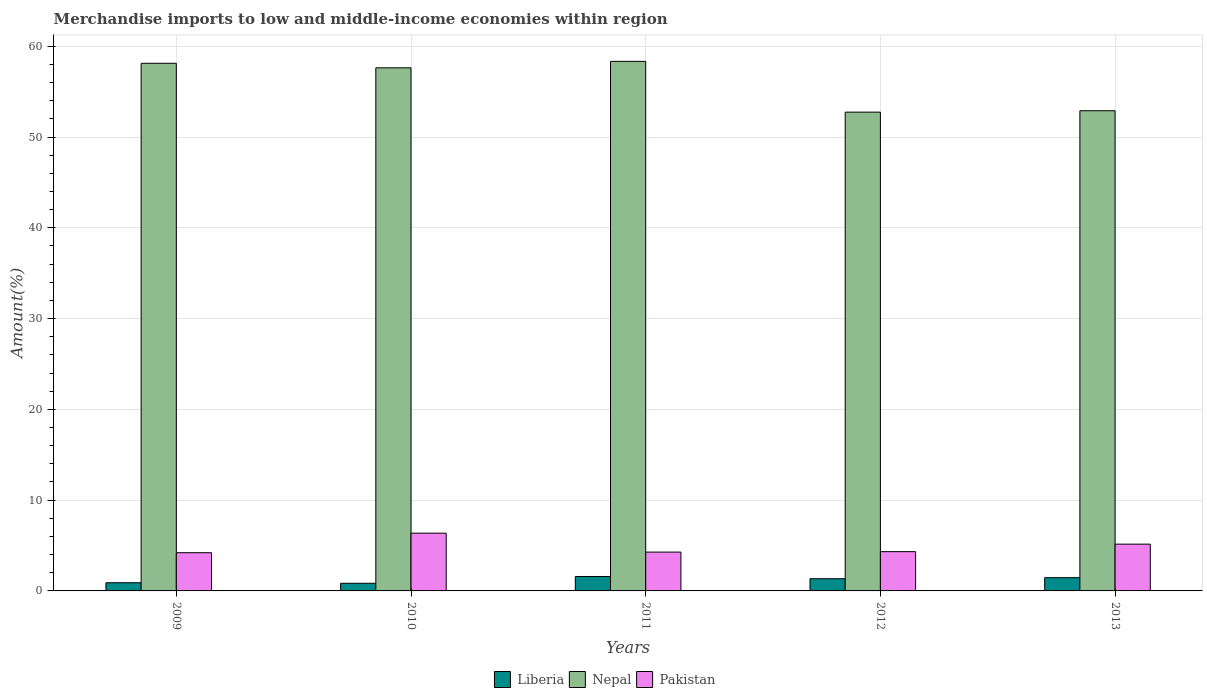How many groups of bars are there?
Offer a very short reply. 5. Are the number of bars per tick equal to the number of legend labels?
Ensure brevity in your answer.  Yes. How many bars are there on the 2nd tick from the right?
Offer a very short reply. 3. In how many cases, is the number of bars for a given year not equal to the number of legend labels?
Provide a short and direct response. 0. What is the percentage of amount earned from merchandise imports in Pakistan in 2010?
Provide a short and direct response. 6.36. Across all years, what is the maximum percentage of amount earned from merchandise imports in Nepal?
Give a very brief answer. 58.33. Across all years, what is the minimum percentage of amount earned from merchandise imports in Pakistan?
Provide a succinct answer. 4.21. In which year was the percentage of amount earned from merchandise imports in Liberia maximum?
Your answer should be compact. 2011. In which year was the percentage of amount earned from merchandise imports in Pakistan minimum?
Your answer should be very brief. 2009. What is the total percentage of amount earned from merchandise imports in Liberia in the graph?
Keep it short and to the point. 6.13. What is the difference between the percentage of amount earned from merchandise imports in Nepal in 2011 and that in 2013?
Your response must be concise. 5.44. What is the difference between the percentage of amount earned from merchandise imports in Pakistan in 2011 and the percentage of amount earned from merchandise imports in Liberia in 2009?
Offer a very short reply. 3.38. What is the average percentage of amount earned from merchandise imports in Liberia per year?
Ensure brevity in your answer.  1.23. In the year 2010, what is the difference between the percentage of amount earned from merchandise imports in Liberia and percentage of amount earned from merchandise imports in Nepal?
Your answer should be very brief. -56.78. In how many years, is the percentage of amount earned from merchandise imports in Pakistan greater than 36 %?
Give a very brief answer. 0. What is the ratio of the percentage of amount earned from merchandise imports in Nepal in 2009 to that in 2012?
Keep it short and to the point. 1.1. Is the percentage of amount earned from merchandise imports in Pakistan in 2010 less than that in 2012?
Offer a terse response. No. Is the difference between the percentage of amount earned from merchandise imports in Liberia in 2010 and 2012 greater than the difference between the percentage of amount earned from merchandise imports in Nepal in 2010 and 2012?
Provide a short and direct response. No. What is the difference between the highest and the second highest percentage of amount earned from merchandise imports in Nepal?
Give a very brief answer. 0.21. What is the difference between the highest and the lowest percentage of amount earned from merchandise imports in Liberia?
Make the answer very short. 0.75. Is the sum of the percentage of amount earned from merchandise imports in Nepal in 2009 and 2012 greater than the maximum percentage of amount earned from merchandise imports in Liberia across all years?
Give a very brief answer. Yes. What does the 2nd bar from the left in 2013 represents?
Keep it short and to the point. Nepal. What does the 3rd bar from the right in 2011 represents?
Provide a short and direct response. Liberia. How many bars are there?
Your answer should be compact. 15. What is the difference between two consecutive major ticks on the Y-axis?
Offer a very short reply. 10. Does the graph contain grids?
Provide a succinct answer. Yes. How many legend labels are there?
Provide a short and direct response. 3. How are the legend labels stacked?
Provide a short and direct response. Horizontal. What is the title of the graph?
Your answer should be very brief. Merchandise imports to low and middle-income economies within region. What is the label or title of the Y-axis?
Keep it short and to the point. Amount(%). What is the Amount(%) in Liberia in 2009?
Give a very brief answer. 0.9. What is the Amount(%) in Nepal in 2009?
Ensure brevity in your answer.  58.12. What is the Amount(%) of Pakistan in 2009?
Provide a succinct answer. 4.21. What is the Amount(%) in Liberia in 2010?
Provide a succinct answer. 0.84. What is the Amount(%) of Nepal in 2010?
Your answer should be compact. 57.62. What is the Amount(%) in Pakistan in 2010?
Provide a short and direct response. 6.36. What is the Amount(%) in Liberia in 2011?
Provide a short and direct response. 1.59. What is the Amount(%) of Nepal in 2011?
Make the answer very short. 58.33. What is the Amount(%) in Pakistan in 2011?
Your answer should be compact. 4.28. What is the Amount(%) of Liberia in 2012?
Provide a short and direct response. 1.34. What is the Amount(%) in Nepal in 2012?
Give a very brief answer. 52.74. What is the Amount(%) in Pakistan in 2012?
Give a very brief answer. 4.33. What is the Amount(%) in Liberia in 2013?
Provide a succinct answer. 1.46. What is the Amount(%) in Nepal in 2013?
Your response must be concise. 52.89. What is the Amount(%) in Pakistan in 2013?
Ensure brevity in your answer.  5.15. Across all years, what is the maximum Amount(%) of Liberia?
Offer a very short reply. 1.59. Across all years, what is the maximum Amount(%) in Nepal?
Make the answer very short. 58.33. Across all years, what is the maximum Amount(%) in Pakistan?
Your response must be concise. 6.36. Across all years, what is the minimum Amount(%) in Liberia?
Give a very brief answer. 0.84. Across all years, what is the minimum Amount(%) in Nepal?
Offer a terse response. 52.74. Across all years, what is the minimum Amount(%) of Pakistan?
Keep it short and to the point. 4.21. What is the total Amount(%) of Liberia in the graph?
Make the answer very short. 6.13. What is the total Amount(%) in Nepal in the graph?
Offer a very short reply. 279.71. What is the total Amount(%) in Pakistan in the graph?
Give a very brief answer. 24.33. What is the difference between the Amount(%) of Liberia in 2009 and that in 2010?
Provide a short and direct response. 0.06. What is the difference between the Amount(%) of Nepal in 2009 and that in 2010?
Your answer should be compact. 0.5. What is the difference between the Amount(%) of Pakistan in 2009 and that in 2010?
Provide a succinct answer. -2.15. What is the difference between the Amount(%) of Liberia in 2009 and that in 2011?
Your answer should be very brief. -0.69. What is the difference between the Amount(%) in Nepal in 2009 and that in 2011?
Ensure brevity in your answer.  -0.21. What is the difference between the Amount(%) of Pakistan in 2009 and that in 2011?
Your answer should be compact. -0.07. What is the difference between the Amount(%) of Liberia in 2009 and that in 2012?
Offer a terse response. -0.44. What is the difference between the Amount(%) in Nepal in 2009 and that in 2012?
Your answer should be very brief. 5.38. What is the difference between the Amount(%) in Pakistan in 2009 and that in 2012?
Keep it short and to the point. -0.12. What is the difference between the Amount(%) in Liberia in 2009 and that in 2013?
Your answer should be very brief. -0.56. What is the difference between the Amount(%) of Nepal in 2009 and that in 2013?
Your response must be concise. 5.23. What is the difference between the Amount(%) of Pakistan in 2009 and that in 2013?
Make the answer very short. -0.94. What is the difference between the Amount(%) in Liberia in 2010 and that in 2011?
Offer a very short reply. -0.75. What is the difference between the Amount(%) of Nepal in 2010 and that in 2011?
Provide a succinct answer. -0.71. What is the difference between the Amount(%) in Pakistan in 2010 and that in 2011?
Ensure brevity in your answer.  2.08. What is the difference between the Amount(%) in Liberia in 2010 and that in 2012?
Give a very brief answer. -0.5. What is the difference between the Amount(%) in Nepal in 2010 and that in 2012?
Give a very brief answer. 4.88. What is the difference between the Amount(%) in Pakistan in 2010 and that in 2012?
Your response must be concise. 2.04. What is the difference between the Amount(%) in Liberia in 2010 and that in 2013?
Offer a terse response. -0.62. What is the difference between the Amount(%) of Nepal in 2010 and that in 2013?
Offer a terse response. 4.73. What is the difference between the Amount(%) in Pakistan in 2010 and that in 2013?
Make the answer very short. 1.21. What is the difference between the Amount(%) of Liberia in 2011 and that in 2012?
Provide a short and direct response. 0.25. What is the difference between the Amount(%) of Nepal in 2011 and that in 2012?
Make the answer very short. 5.59. What is the difference between the Amount(%) of Pakistan in 2011 and that in 2012?
Offer a very short reply. -0.05. What is the difference between the Amount(%) in Liberia in 2011 and that in 2013?
Your answer should be very brief. 0.13. What is the difference between the Amount(%) in Nepal in 2011 and that in 2013?
Ensure brevity in your answer.  5.44. What is the difference between the Amount(%) of Pakistan in 2011 and that in 2013?
Offer a terse response. -0.87. What is the difference between the Amount(%) in Liberia in 2012 and that in 2013?
Your answer should be very brief. -0.12. What is the difference between the Amount(%) in Nepal in 2012 and that in 2013?
Your answer should be compact. -0.15. What is the difference between the Amount(%) in Pakistan in 2012 and that in 2013?
Offer a terse response. -0.83. What is the difference between the Amount(%) of Liberia in 2009 and the Amount(%) of Nepal in 2010?
Your answer should be very brief. -56.72. What is the difference between the Amount(%) of Liberia in 2009 and the Amount(%) of Pakistan in 2010?
Offer a very short reply. -5.46. What is the difference between the Amount(%) in Nepal in 2009 and the Amount(%) in Pakistan in 2010?
Offer a very short reply. 51.76. What is the difference between the Amount(%) in Liberia in 2009 and the Amount(%) in Nepal in 2011?
Your answer should be compact. -57.43. What is the difference between the Amount(%) in Liberia in 2009 and the Amount(%) in Pakistan in 2011?
Ensure brevity in your answer.  -3.38. What is the difference between the Amount(%) in Nepal in 2009 and the Amount(%) in Pakistan in 2011?
Your answer should be very brief. 53.84. What is the difference between the Amount(%) in Liberia in 2009 and the Amount(%) in Nepal in 2012?
Provide a short and direct response. -51.84. What is the difference between the Amount(%) in Liberia in 2009 and the Amount(%) in Pakistan in 2012?
Your answer should be compact. -3.42. What is the difference between the Amount(%) in Nepal in 2009 and the Amount(%) in Pakistan in 2012?
Ensure brevity in your answer.  53.8. What is the difference between the Amount(%) in Liberia in 2009 and the Amount(%) in Nepal in 2013?
Give a very brief answer. -51.99. What is the difference between the Amount(%) in Liberia in 2009 and the Amount(%) in Pakistan in 2013?
Provide a short and direct response. -4.25. What is the difference between the Amount(%) in Nepal in 2009 and the Amount(%) in Pakistan in 2013?
Your answer should be very brief. 52.97. What is the difference between the Amount(%) of Liberia in 2010 and the Amount(%) of Nepal in 2011?
Keep it short and to the point. -57.49. What is the difference between the Amount(%) of Liberia in 2010 and the Amount(%) of Pakistan in 2011?
Keep it short and to the point. -3.43. What is the difference between the Amount(%) in Nepal in 2010 and the Amount(%) in Pakistan in 2011?
Give a very brief answer. 53.34. What is the difference between the Amount(%) of Liberia in 2010 and the Amount(%) of Nepal in 2012?
Your answer should be very brief. -51.9. What is the difference between the Amount(%) in Liberia in 2010 and the Amount(%) in Pakistan in 2012?
Provide a short and direct response. -3.48. What is the difference between the Amount(%) in Nepal in 2010 and the Amount(%) in Pakistan in 2012?
Give a very brief answer. 53.3. What is the difference between the Amount(%) in Liberia in 2010 and the Amount(%) in Nepal in 2013?
Your answer should be compact. -52.05. What is the difference between the Amount(%) of Liberia in 2010 and the Amount(%) of Pakistan in 2013?
Give a very brief answer. -4.31. What is the difference between the Amount(%) of Nepal in 2010 and the Amount(%) of Pakistan in 2013?
Your response must be concise. 52.47. What is the difference between the Amount(%) of Liberia in 2011 and the Amount(%) of Nepal in 2012?
Make the answer very short. -51.15. What is the difference between the Amount(%) in Liberia in 2011 and the Amount(%) in Pakistan in 2012?
Give a very brief answer. -2.74. What is the difference between the Amount(%) in Nepal in 2011 and the Amount(%) in Pakistan in 2012?
Provide a short and direct response. 54.01. What is the difference between the Amount(%) of Liberia in 2011 and the Amount(%) of Nepal in 2013?
Offer a very short reply. -51.3. What is the difference between the Amount(%) of Liberia in 2011 and the Amount(%) of Pakistan in 2013?
Offer a very short reply. -3.56. What is the difference between the Amount(%) in Nepal in 2011 and the Amount(%) in Pakistan in 2013?
Make the answer very short. 53.18. What is the difference between the Amount(%) of Liberia in 2012 and the Amount(%) of Nepal in 2013?
Provide a succinct answer. -51.55. What is the difference between the Amount(%) in Liberia in 2012 and the Amount(%) in Pakistan in 2013?
Provide a succinct answer. -3.81. What is the difference between the Amount(%) in Nepal in 2012 and the Amount(%) in Pakistan in 2013?
Offer a very short reply. 47.59. What is the average Amount(%) in Liberia per year?
Offer a terse response. 1.23. What is the average Amount(%) of Nepal per year?
Your answer should be compact. 55.94. What is the average Amount(%) in Pakistan per year?
Give a very brief answer. 4.87. In the year 2009, what is the difference between the Amount(%) in Liberia and Amount(%) in Nepal?
Offer a terse response. -57.22. In the year 2009, what is the difference between the Amount(%) of Liberia and Amount(%) of Pakistan?
Your answer should be compact. -3.31. In the year 2009, what is the difference between the Amount(%) of Nepal and Amount(%) of Pakistan?
Ensure brevity in your answer.  53.91. In the year 2010, what is the difference between the Amount(%) in Liberia and Amount(%) in Nepal?
Provide a short and direct response. -56.78. In the year 2010, what is the difference between the Amount(%) in Liberia and Amount(%) in Pakistan?
Ensure brevity in your answer.  -5.52. In the year 2010, what is the difference between the Amount(%) in Nepal and Amount(%) in Pakistan?
Ensure brevity in your answer.  51.26. In the year 2011, what is the difference between the Amount(%) of Liberia and Amount(%) of Nepal?
Your answer should be very brief. -56.75. In the year 2011, what is the difference between the Amount(%) of Liberia and Amount(%) of Pakistan?
Make the answer very short. -2.69. In the year 2011, what is the difference between the Amount(%) in Nepal and Amount(%) in Pakistan?
Give a very brief answer. 54.06. In the year 2012, what is the difference between the Amount(%) of Liberia and Amount(%) of Nepal?
Keep it short and to the point. -51.4. In the year 2012, what is the difference between the Amount(%) of Liberia and Amount(%) of Pakistan?
Your answer should be compact. -2.98. In the year 2012, what is the difference between the Amount(%) of Nepal and Amount(%) of Pakistan?
Your response must be concise. 48.41. In the year 2013, what is the difference between the Amount(%) of Liberia and Amount(%) of Nepal?
Your answer should be compact. -51.43. In the year 2013, what is the difference between the Amount(%) of Liberia and Amount(%) of Pakistan?
Your answer should be very brief. -3.69. In the year 2013, what is the difference between the Amount(%) in Nepal and Amount(%) in Pakistan?
Ensure brevity in your answer.  47.74. What is the ratio of the Amount(%) of Liberia in 2009 to that in 2010?
Your answer should be very brief. 1.07. What is the ratio of the Amount(%) of Nepal in 2009 to that in 2010?
Make the answer very short. 1.01. What is the ratio of the Amount(%) of Pakistan in 2009 to that in 2010?
Make the answer very short. 0.66. What is the ratio of the Amount(%) of Liberia in 2009 to that in 2011?
Your answer should be compact. 0.57. What is the ratio of the Amount(%) of Nepal in 2009 to that in 2011?
Your response must be concise. 1. What is the ratio of the Amount(%) in Pakistan in 2009 to that in 2011?
Give a very brief answer. 0.98. What is the ratio of the Amount(%) of Liberia in 2009 to that in 2012?
Your answer should be compact. 0.67. What is the ratio of the Amount(%) in Nepal in 2009 to that in 2012?
Ensure brevity in your answer.  1.1. What is the ratio of the Amount(%) of Liberia in 2009 to that in 2013?
Your response must be concise. 0.62. What is the ratio of the Amount(%) in Nepal in 2009 to that in 2013?
Give a very brief answer. 1.1. What is the ratio of the Amount(%) in Pakistan in 2009 to that in 2013?
Give a very brief answer. 0.82. What is the ratio of the Amount(%) in Liberia in 2010 to that in 2011?
Provide a short and direct response. 0.53. What is the ratio of the Amount(%) in Nepal in 2010 to that in 2011?
Your answer should be compact. 0.99. What is the ratio of the Amount(%) of Pakistan in 2010 to that in 2011?
Make the answer very short. 1.49. What is the ratio of the Amount(%) in Liberia in 2010 to that in 2012?
Ensure brevity in your answer.  0.63. What is the ratio of the Amount(%) of Nepal in 2010 to that in 2012?
Offer a very short reply. 1.09. What is the ratio of the Amount(%) in Pakistan in 2010 to that in 2012?
Offer a terse response. 1.47. What is the ratio of the Amount(%) of Liberia in 2010 to that in 2013?
Offer a terse response. 0.58. What is the ratio of the Amount(%) in Nepal in 2010 to that in 2013?
Your answer should be very brief. 1.09. What is the ratio of the Amount(%) in Pakistan in 2010 to that in 2013?
Keep it short and to the point. 1.24. What is the ratio of the Amount(%) of Liberia in 2011 to that in 2012?
Offer a very short reply. 1.18. What is the ratio of the Amount(%) of Nepal in 2011 to that in 2012?
Your response must be concise. 1.11. What is the ratio of the Amount(%) of Pakistan in 2011 to that in 2012?
Offer a terse response. 0.99. What is the ratio of the Amount(%) in Liberia in 2011 to that in 2013?
Ensure brevity in your answer.  1.09. What is the ratio of the Amount(%) in Nepal in 2011 to that in 2013?
Ensure brevity in your answer.  1.1. What is the ratio of the Amount(%) in Pakistan in 2011 to that in 2013?
Offer a terse response. 0.83. What is the ratio of the Amount(%) in Liberia in 2012 to that in 2013?
Your response must be concise. 0.92. What is the ratio of the Amount(%) of Nepal in 2012 to that in 2013?
Provide a succinct answer. 1. What is the ratio of the Amount(%) of Pakistan in 2012 to that in 2013?
Give a very brief answer. 0.84. What is the difference between the highest and the second highest Amount(%) of Liberia?
Offer a terse response. 0.13. What is the difference between the highest and the second highest Amount(%) in Nepal?
Ensure brevity in your answer.  0.21. What is the difference between the highest and the second highest Amount(%) of Pakistan?
Your answer should be very brief. 1.21. What is the difference between the highest and the lowest Amount(%) in Liberia?
Make the answer very short. 0.75. What is the difference between the highest and the lowest Amount(%) in Nepal?
Make the answer very short. 5.59. What is the difference between the highest and the lowest Amount(%) of Pakistan?
Offer a terse response. 2.15. 